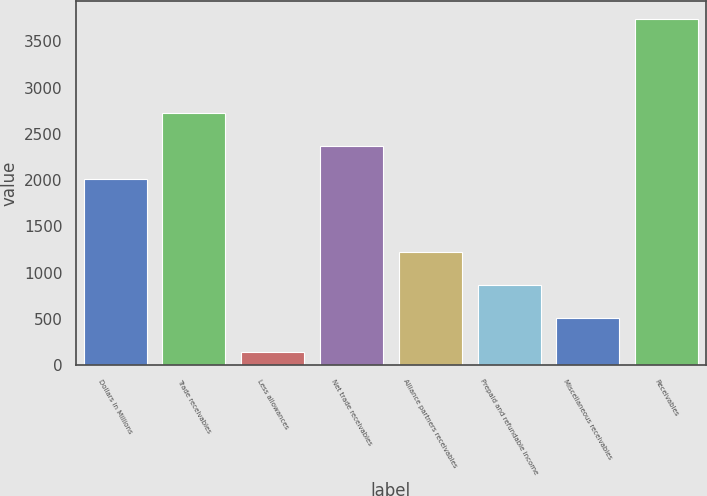Convert chart. <chart><loc_0><loc_0><loc_500><loc_500><bar_chart><fcel>Dollars in Millions<fcel>Trade receivables<fcel>Less allowances<fcel>Net trade receivables<fcel>Alliance partners receivables<fcel>Prepaid and refundable income<fcel>Miscellaneous receivables<fcel>Receivables<nl><fcel>2011<fcel>2730.2<fcel>147<fcel>2370.6<fcel>1225.8<fcel>866.2<fcel>506.6<fcel>3743<nl></chart> 